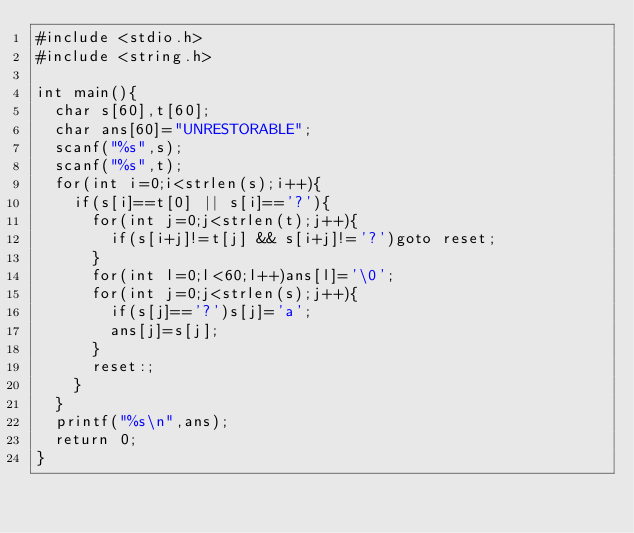Convert code to text. <code><loc_0><loc_0><loc_500><loc_500><_C_>#include <stdio.h>
#include <string.h>

int main(){
  char s[60],t[60];
  char ans[60]="UNRESTORABLE";
  scanf("%s",s);
  scanf("%s",t);
  for(int i=0;i<strlen(s);i++){
    if(s[i]==t[0] || s[i]=='?'){
      for(int j=0;j<strlen(t);j++){
        if(s[i+j]!=t[j] && s[i+j]!='?')goto reset;
      }
      for(int l=0;l<60;l++)ans[l]='\0';
      for(int j=0;j<strlen(s);j++){
        if(s[j]=='?')s[j]='a';
        ans[j]=s[j];
      }
      reset:;
    }
  }
  printf("%s\n",ans);
  return 0;
}
</code> 